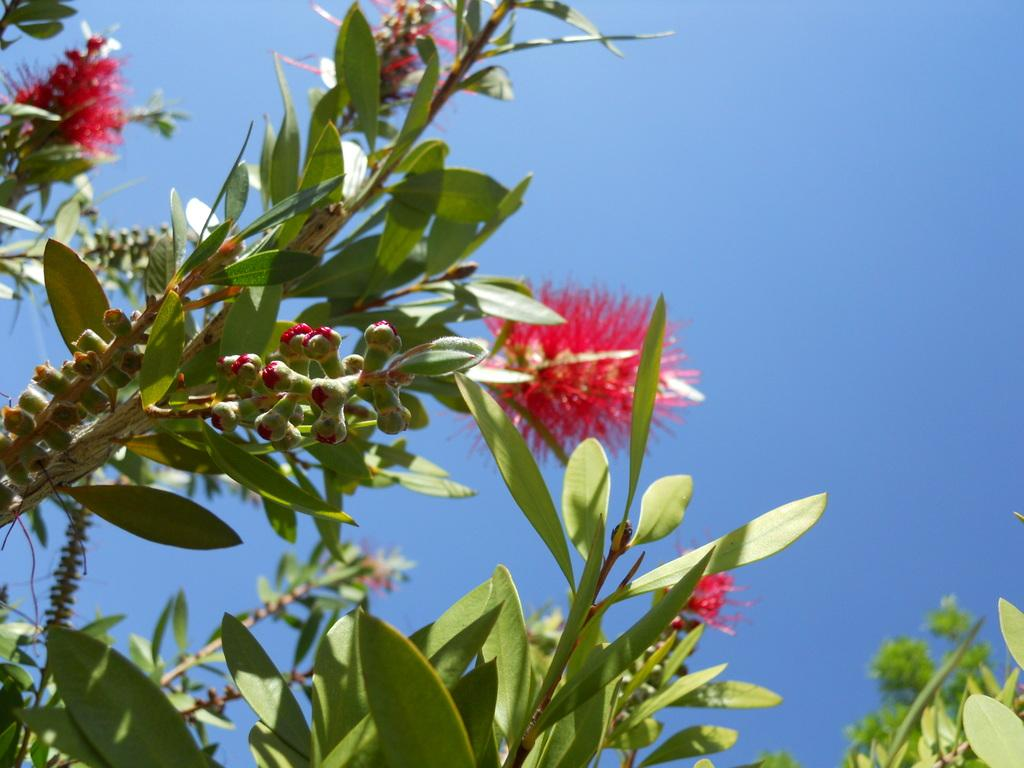What type of plant is present in the image? There is a plant with pink flowers in the image. What can be seen in the background of the image? The sky is visible in the background of the image. What type of nose can be seen on the plant in the image? There is no nose present on the plant in the image, as plants do not have noses. 